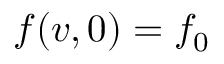Convert formula to latex. <formula><loc_0><loc_0><loc_500><loc_500>f ( v , 0 ) = f _ { 0 }</formula> 